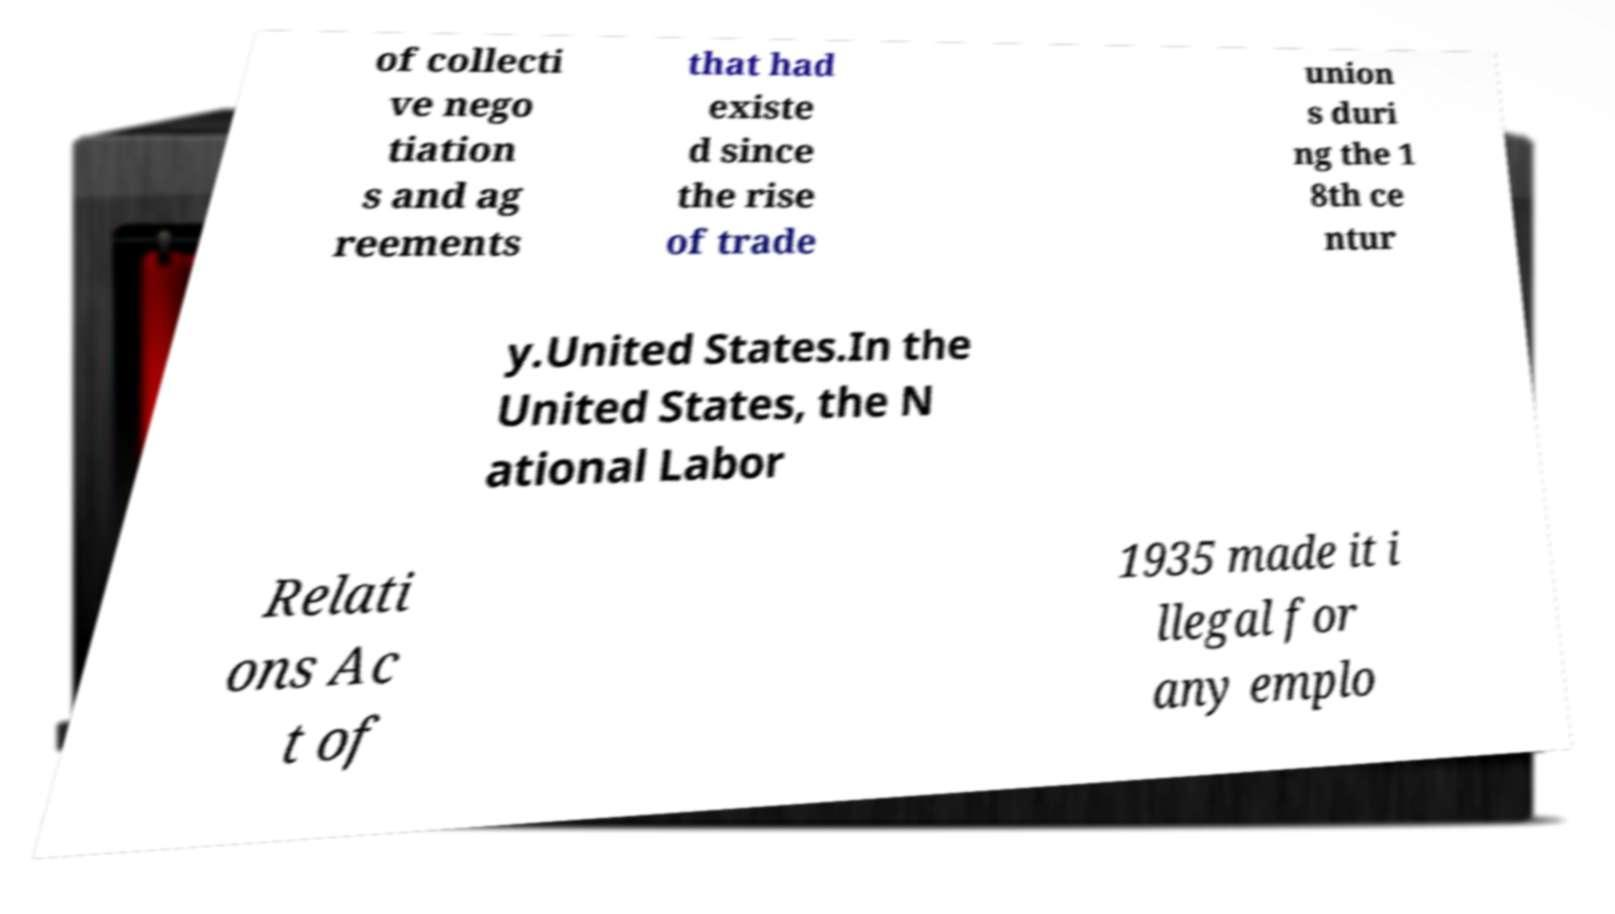Please identify and transcribe the text found in this image. of collecti ve nego tiation s and ag reements that had existe d since the rise of trade union s duri ng the 1 8th ce ntur y.United States.In the United States, the N ational Labor Relati ons Ac t of 1935 made it i llegal for any emplo 